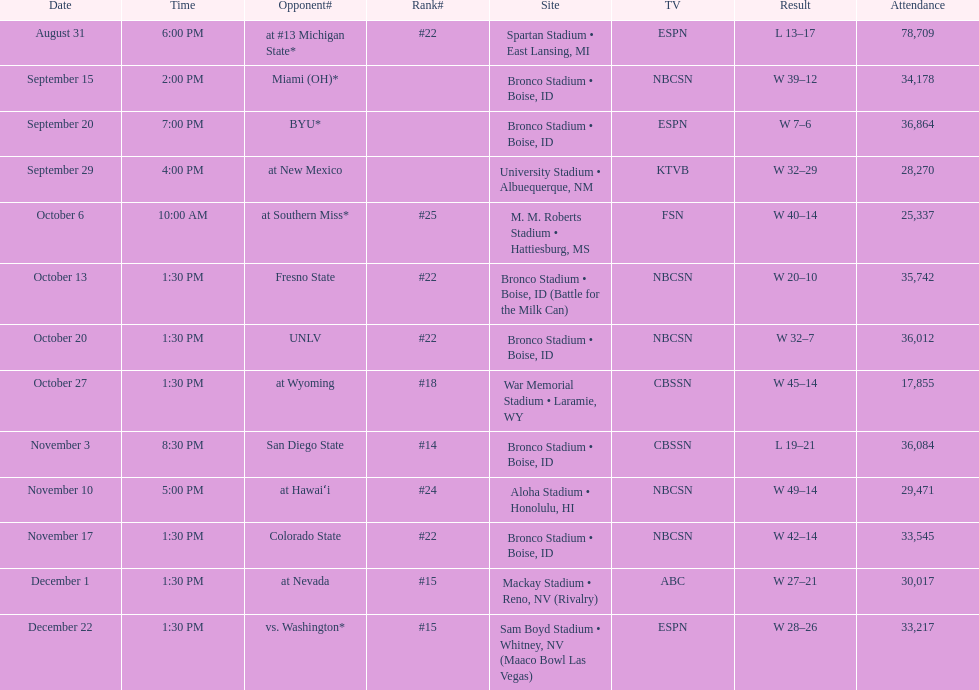In the game against the broncos, what was the total score for miami (oh)? 12. 